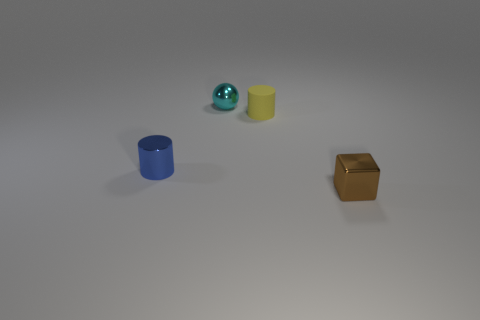Add 3 blue matte cylinders. How many objects exist? 7 Subtract 1 balls. How many balls are left? 0 Subtract all blue cylinders. How many cylinders are left? 1 Add 1 yellow objects. How many yellow objects are left? 2 Add 1 tiny cyan matte spheres. How many tiny cyan matte spheres exist? 1 Subtract 0 purple spheres. How many objects are left? 4 Subtract all blocks. How many objects are left? 3 Subtract all cyan blocks. Subtract all gray spheres. How many blocks are left? 1 Subtract all green cubes. How many yellow cylinders are left? 1 Subtract all cyan shiny spheres. Subtract all small spheres. How many objects are left? 2 